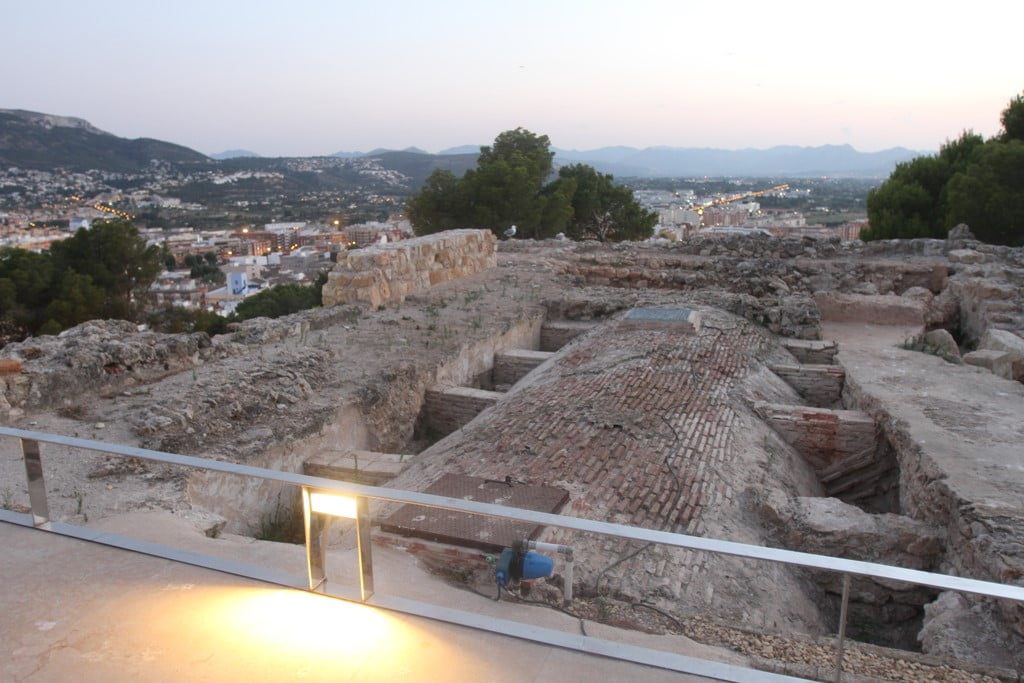Can you describe the function of the structures seen in this image during their time of use? These ruins, likely from Roman times, appear to be part of a larger historical complex possibly used for civic or religious purposes. The discernible features, such as the layered brick and stone work, suggest they might have been part of a public bath or forum, where citizens gathered for social, political, and sanitation purposes. The historical significance of such ruins hints at a bustling center of early civilization, thriving with communal interactions. 